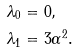<formula> <loc_0><loc_0><loc_500><loc_500>\lambda _ { 0 } & = 0 , \\ \lambda _ { 1 } & = 3 \alpha ^ { 2 } .</formula> 